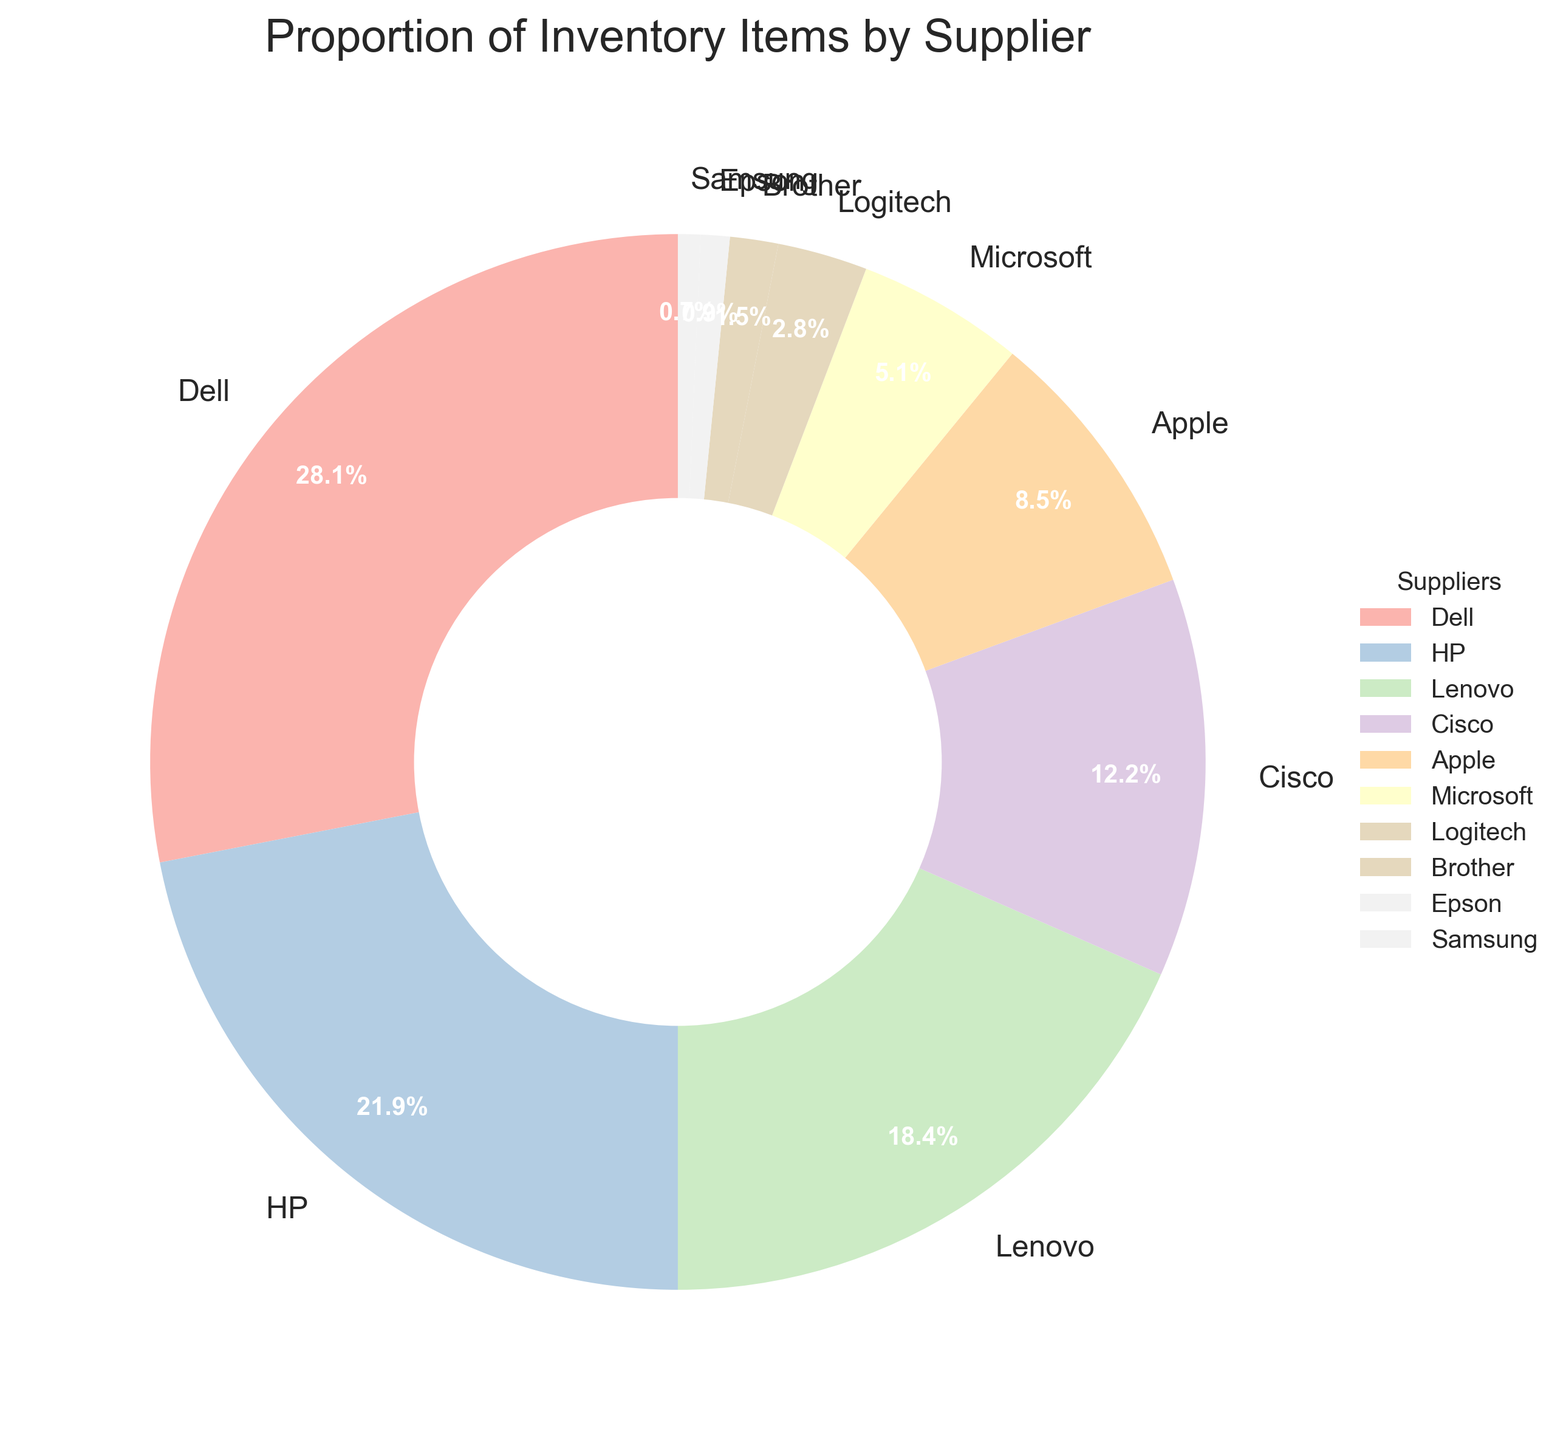Which supplier has the highest proportion of inventory items? By examining the pie chart, the segment for Dell appears to be the largest. The label on Dell's segment shows 28.5%, which is the highest proportion among all suppliers.
Answer: Dell Which two suppliers combined account for more than 50% of the inventory items? By summing the proportions of Dell (28.5%) and HP (22.3%), the total is 28.5 + 22.3 = 50.8%, which is more than 50%. Thus, these two suppliers combined account for more than 50% of the inventory.
Answer: Dell and HP How does the proportion of inventory items from Apple compare to that from Cisco? The proportion of inventory items from Apple is 8.6%, while that from Cisco is 12.4%. Comparing these values, Cisco has a higher proportion than Apple.
Answer: Cisco has a higher proportion What is the average proportion of inventory items from HP, Lenovo, and Microsoft combined? The proportions for HP, Lenovo, and Microsoft are 22.3%, 18.7%, and 5.2% respectively. Adding these proportions gives 22.3 + 18.7 + 5.2 = 46.2%. To find the average, divide this sum by 3, resulting in 46.2 / 3 = 15.4%.
Answer: 15.4% What is the difference in proportion between the supplier with the most inventory items and the supplier with the least? Dell has the most inventory items with 28.5%, and Samsung has the least with 0.7%. The difference is 28.5 - 0.7 = 27.8%.
Answer: 27.8% What is the total proportion of inventory items from Cisco, Logitech, Brother, and Epson? The proportions for Cisco, Logitech, Brother, and Epson are 12.4%, 2.8%, 1.5%, and 0.9% respectively. Summing these values gives 12.4 + 2.8 + 1.5 + 0.9 = 17.6%.
Answer: 17.6% Which supplier has a smaller proportion of inventory items, Epson or Brother? By comparing their proportions, Epson has 0.9% and Brother has 1.5%. Epson's proportion is smaller than Brother's.
Answer: Epson How many suppliers have a proportion of inventory items that is less than 10%? Observing the pie chart, we see that Apple (8.6%), Microsoft (5.2%), Logitech (2.8%), Brother (1.5%), Epson (0.9%), and Samsung (0.7%) all have proportions less than 10%. This totals 6 suppliers.
Answer: 6 suppliers Is the total proportion of inventory items from Lenovo and Logitech greater than that from HP alone? Lenovo's proportion is 18.7% and Logitech's is 2.8%. Adding these gives 18.7 + 2.8 = 21.5%. HP's proportion is 22.3%, which is slightly greater than 21.5%.
Answer: No Which three suppliers, if combined, would make up the smallest total proportion of inventory items? The smallest individual proportions are from Samsung (0.7%), Epson (0.9%), and Brother (1.5%). Adding these gives 0.7 + 0.9 + 1.5 = 3.1%, which is the smallest combined total.
Answer: Samsung, Epson, and Brother 